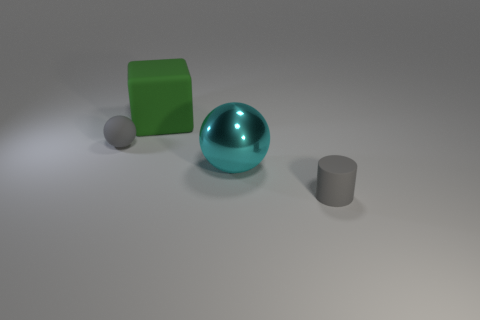Add 1 cubes. How many objects exist? 5 Subtract all blocks. How many objects are left? 3 Add 4 large balls. How many large balls are left? 5 Add 3 big purple metal things. How many big purple metal things exist? 3 Subtract 0 blue blocks. How many objects are left? 4 Subtract all large cyan objects. Subtract all big balls. How many objects are left? 2 